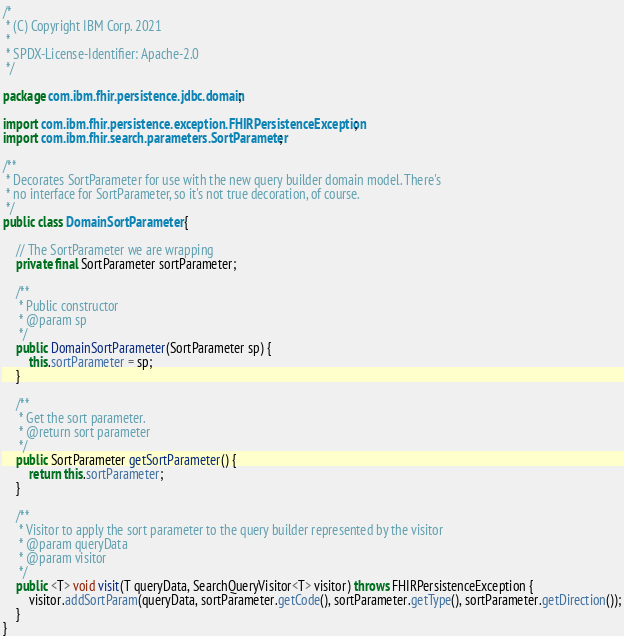<code> <loc_0><loc_0><loc_500><loc_500><_Java_>/*
 * (C) Copyright IBM Corp. 2021
 *
 * SPDX-License-Identifier: Apache-2.0
 */

package com.ibm.fhir.persistence.jdbc.domain;

import com.ibm.fhir.persistence.exception.FHIRPersistenceException;
import com.ibm.fhir.search.parameters.SortParameter;

/**
 * Decorates SortParameter for use with the new query builder domain model. There's
 * no interface for SortParameter, so it's not true decoration, of course.
 */
public class DomainSortParameter {

    // The SortParameter we are wrapping
    private final SortParameter sortParameter;

    /**
     * Public constructor
     * @param sp
     */
    public DomainSortParameter(SortParameter sp) {
        this.sortParameter = sp;
    }

    /**
     * Get the sort parameter.
     * @return sort parameter
     */
    public SortParameter getSortParameter() {
        return this.sortParameter;
    }

    /**
     * Visitor to apply the sort parameter to the query builder represented by the visitor
     * @param queryData
     * @param visitor
     */
    public <T> void visit(T queryData, SearchQueryVisitor<T> visitor) throws FHIRPersistenceException {
        visitor.addSortParam(queryData, sortParameter.getCode(), sortParameter.getType(), sortParameter.getDirection());
    }
}</code> 